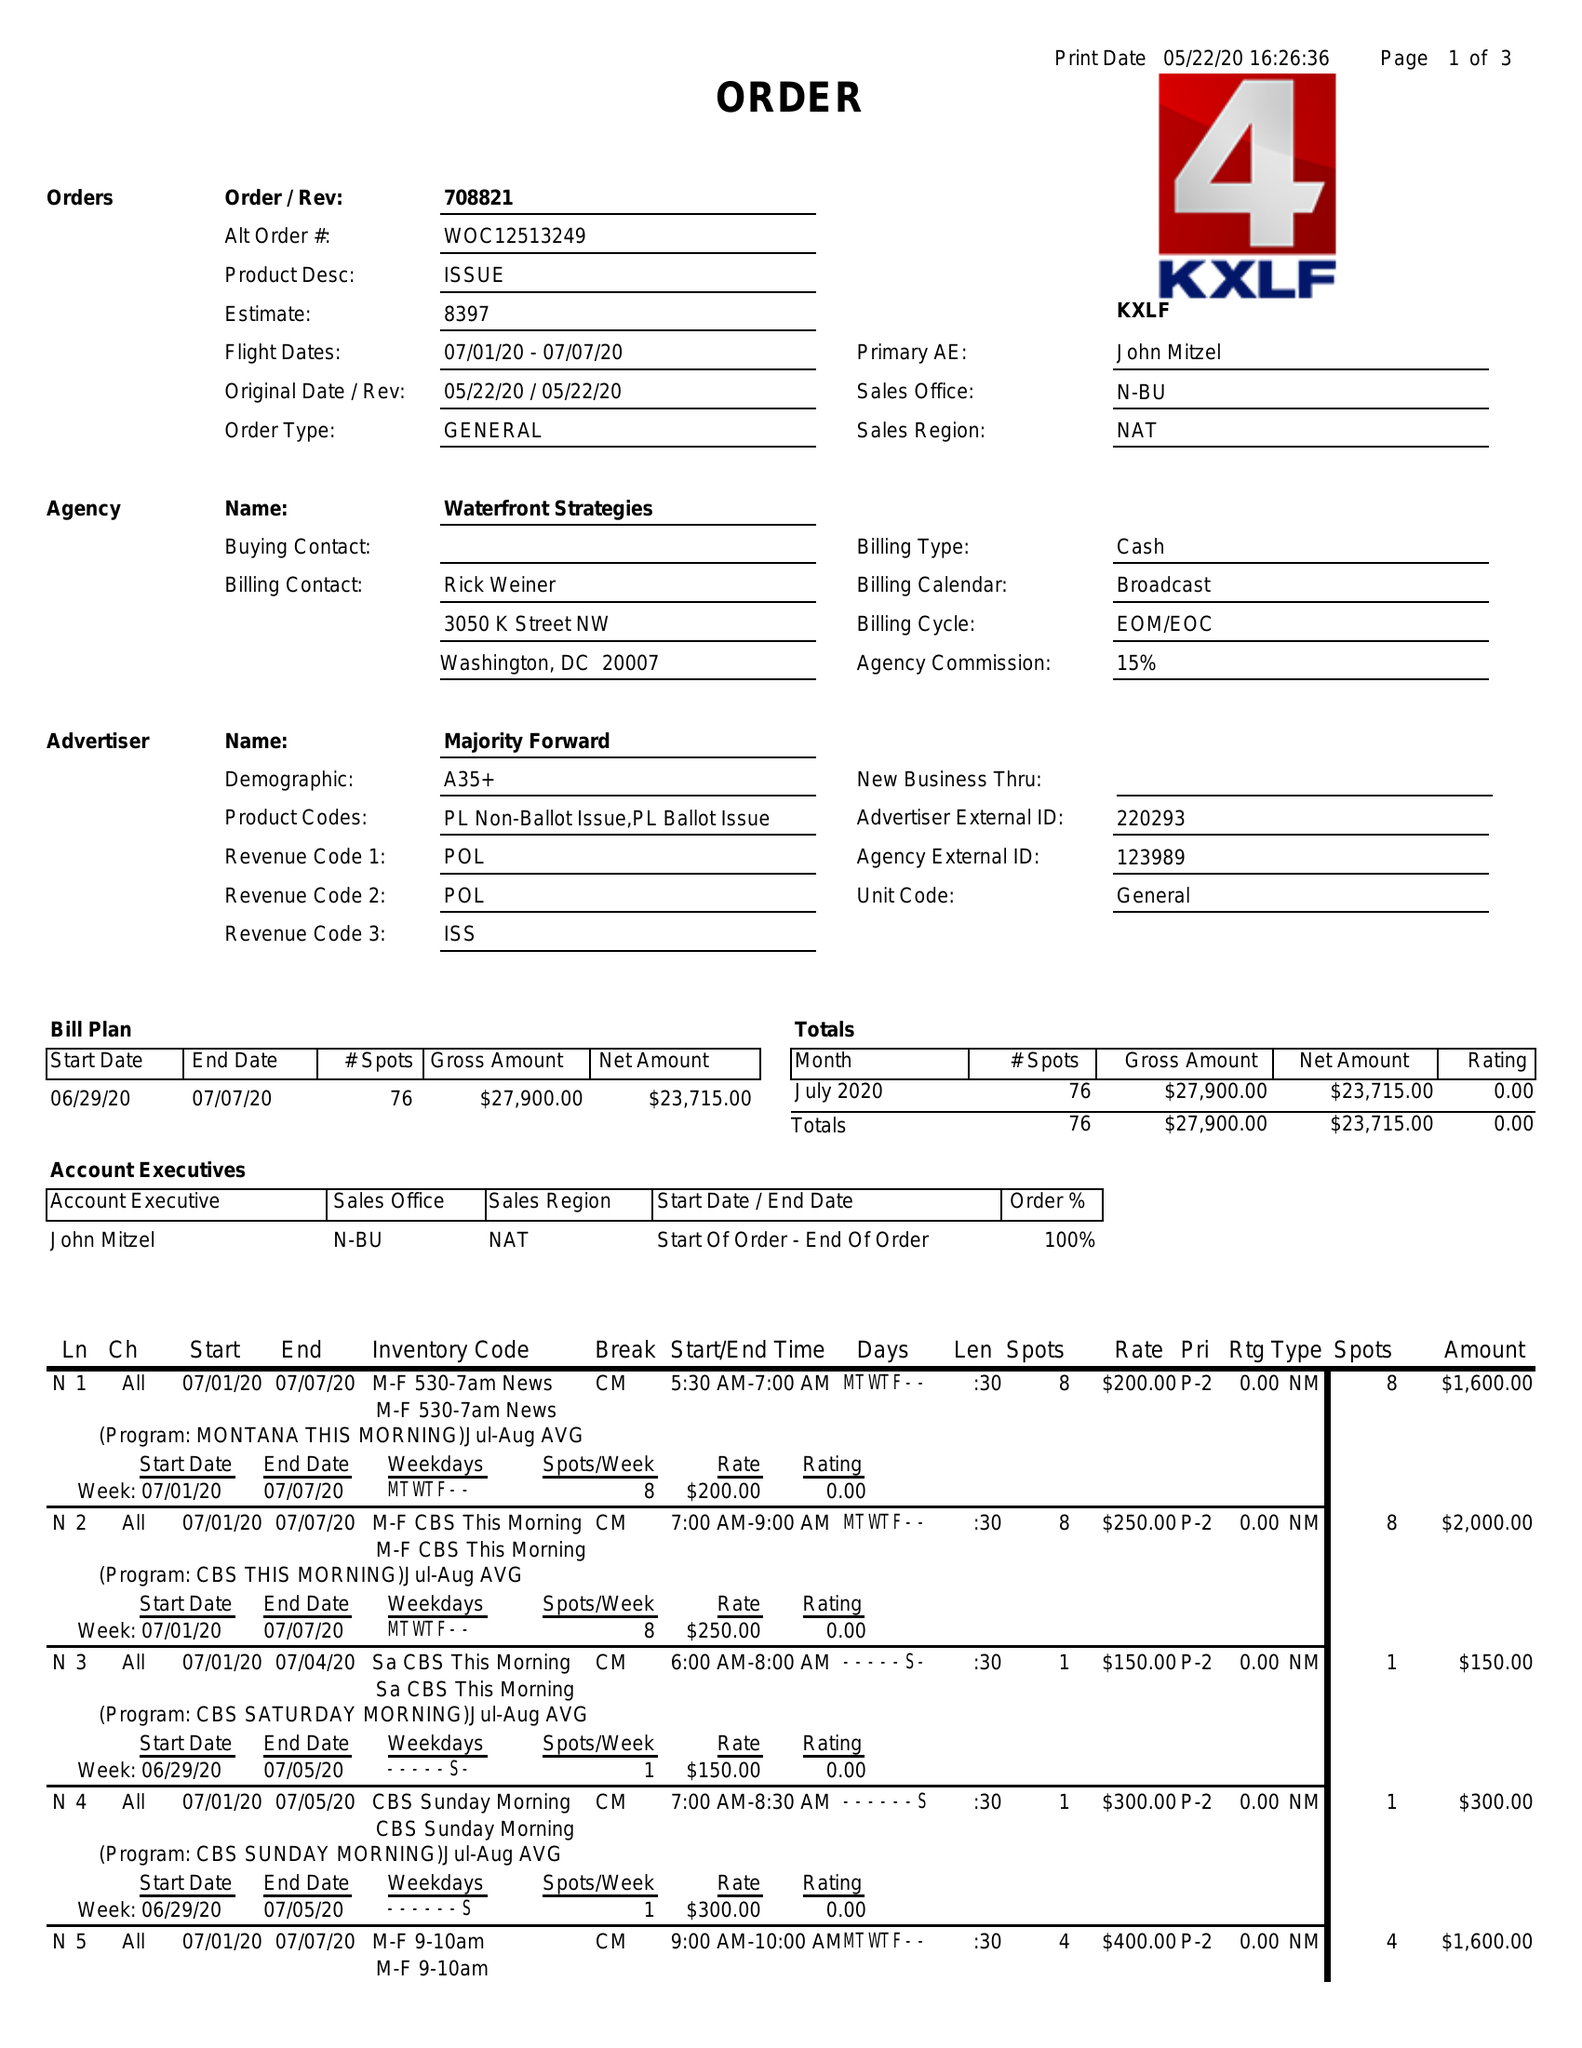What is the value for the gross_amount?
Answer the question using a single word or phrase. 27900.00 